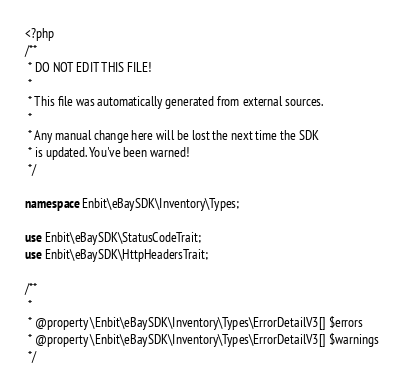Convert code to text. <code><loc_0><loc_0><loc_500><loc_500><_PHP_><?php
/**
 * DO NOT EDIT THIS FILE!
 *
 * This file was automatically generated from external sources.
 *
 * Any manual change here will be lost the next time the SDK
 * is updated. You've been warned!
 */

namespace Enbit\eBaySDK\Inventory\Types;

use Enbit\eBaySDK\StatusCodeTrait;
use Enbit\eBaySDK\HttpHeadersTrait;

/**
 *
 * @property \Enbit\eBaySDK\Inventory\Types\ErrorDetailV3[] $errors
 * @property \Enbit\eBaySDK\Inventory\Types\ErrorDetailV3[] $warnings
 */</code> 